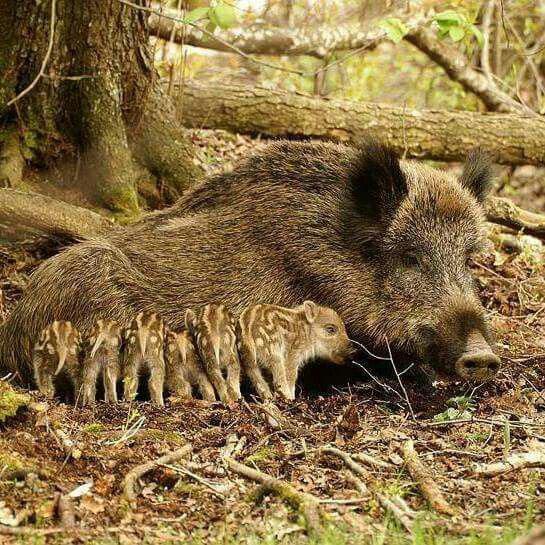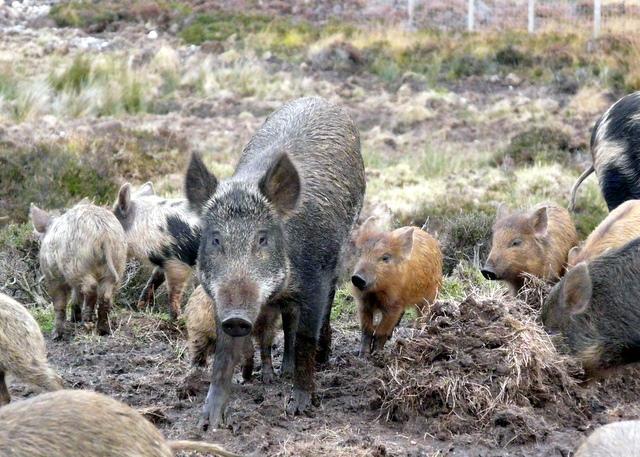The first image is the image on the left, the second image is the image on the right. Given the left and right images, does the statement "There are two animals in total." hold true? Answer yes or no. No. The first image is the image on the left, the second image is the image on the right. For the images displayed, is the sentence "A weapon is visible next to a dead hog in one image." factually correct? Answer yes or no. No. 